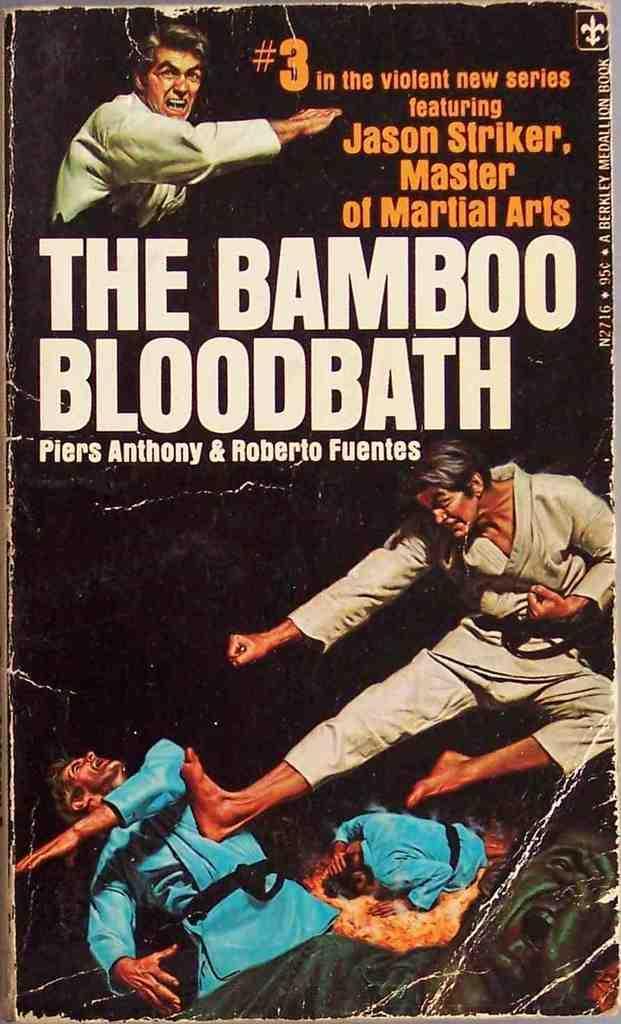How would you summarize this image in a sentence or two? In this image we can see the front view of a book with the text and also the people. 